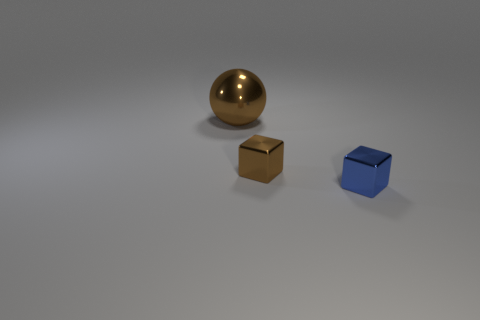There is a small thing that is behind the blue metal cube; what is its shape?
Offer a very short reply. Cube. There is another object that is the same shape as the small blue thing; what is its size?
Provide a short and direct response. Small. Is there any other thing that has the same shape as the big brown metal thing?
Your answer should be very brief. No. Is there a large brown metal thing that is right of the tiny blue object in front of the brown shiny block?
Your answer should be very brief. No. There is another object that is the same shape as the tiny blue thing; what color is it?
Make the answer very short. Brown. How many big blocks have the same color as the big metal ball?
Your answer should be very brief. 0. There is a block that is on the left side of the small metallic object that is on the right side of the brown shiny object in front of the large thing; what is its color?
Ensure brevity in your answer.  Brown. Does the blue block have the same material as the large object?
Offer a very short reply. Yes. Is the blue metallic thing the same shape as the big brown object?
Offer a terse response. No. Is the number of big balls on the right side of the ball the same as the number of metal objects that are right of the brown cube?
Your answer should be compact. No. 